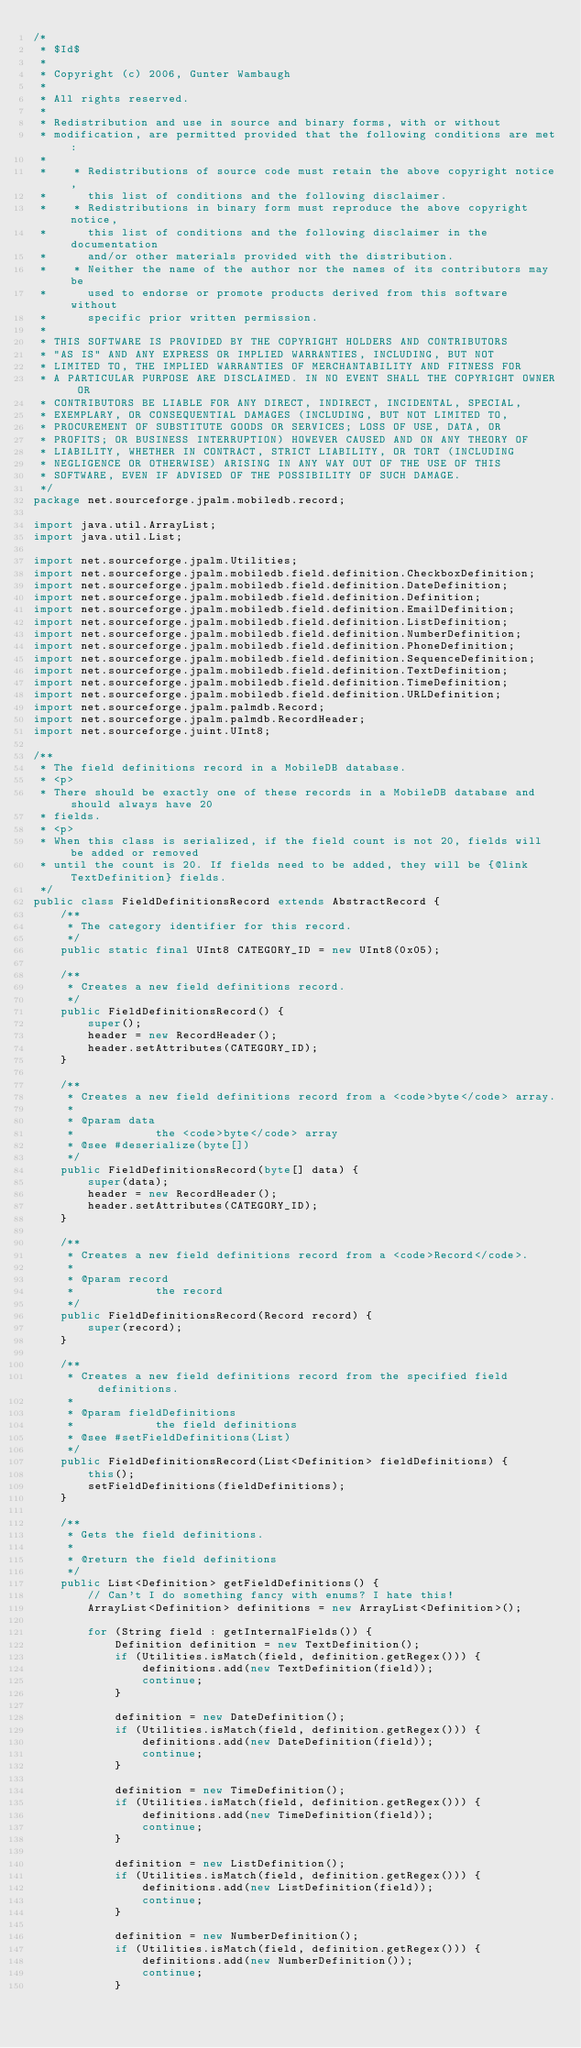Convert code to text. <code><loc_0><loc_0><loc_500><loc_500><_Java_>/*
 * $Id$
 * 
 * Copyright (c) 2006, Gunter Wambaugh
 * 
 * All rights reserved.
 * 
 * Redistribution and use in source and binary forms, with or without
 * modification, are permitted provided that the following conditions are met:
 *
 *    * Redistributions of source code must retain the above copyright notice,
 *      this list of conditions and the following disclaimer.
 *    * Redistributions in binary form must reproduce the above copyright notice,
 *      this list of conditions and the following disclaimer in the documentation
 *      and/or other materials provided with the distribution.
 *    * Neither the name of the author nor the names of its contributors may be
 *      used to endorse or promote products derived from this software without 
 *      specific prior written permission.
 *
 * THIS SOFTWARE IS PROVIDED BY THE COPYRIGHT HOLDERS AND CONTRIBUTORS
 * "AS IS" AND ANY EXPRESS OR IMPLIED WARRANTIES, INCLUDING, BUT NOT
 * LIMITED TO, THE IMPLIED WARRANTIES OF MERCHANTABILITY AND FITNESS FOR
 * A PARTICULAR PURPOSE ARE DISCLAIMED. IN NO EVENT SHALL THE COPYRIGHT OWNER OR
 * CONTRIBUTORS BE LIABLE FOR ANY DIRECT, INDIRECT, INCIDENTAL, SPECIAL,
 * EXEMPLARY, OR CONSEQUENTIAL DAMAGES (INCLUDING, BUT NOT LIMITED TO,
 * PROCUREMENT OF SUBSTITUTE GOODS OR SERVICES; LOSS OF USE, DATA, OR
 * PROFITS; OR BUSINESS INTERRUPTION) HOWEVER CAUSED AND ON ANY THEORY OF
 * LIABILITY, WHETHER IN CONTRACT, STRICT LIABILITY, OR TORT (INCLUDING
 * NEGLIGENCE OR OTHERWISE) ARISING IN ANY WAY OUT OF THE USE OF THIS
 * SOFTWARE, EVEN IF ADVISED OF THE POSSIBILITY OF SUCH DAMAGE.
 */
package net.sourceforge.jpalm.mobiledb.record;

import java.util.ArrayList;
import java.util.List;

import net.sourceforge.jpalm.Utilities;
import net.sourceforge.jpalm.mobiledb.field.definition.CheckboxDefinition;
import net.sourceforge.jpalm.mobiledb.field.definition.DateDefinition;
import net.sourceforge.jpalm.mobiledb.field.definition.Definition;
import net.sourceforge.jpalm.mobiledb.field.definition.EmailDefinition;
import net.sourceforge.jpalm.mobiledb.field.definition.ListDefinition;
import net.sourceforge.jpalm.mobiledb.field.definition.NumberDefinition;
import net.sourceforge.jpalm.mobiledb.field.definition.PhoneDefinition;
import net.sourceforge.jpalm.mobiledb.field.definition.SequenceDefinition;
import net.sourceforge.jpalm.mobiledb.field.definition.TextDefinition;
import net.sourceforge.jpalm.mobiledb.field.definition.TimeDefinition;
import net.sourceforge.jpalm.mobiledb.field.definition.URLDefinition;
import net.sourceforge.jpalm.palmdb.Record;
import net.sourceforge.jpalm.palmdb.RecordHeader;
import net.sourceforge.juint.UInt8;

/**
 * The field definitions record in a MobileDB database.
 * <p>
 * There should be exactly one of these records in a MobileDB database and should always have 20
 * fields.
 * <p>
 * When this class is serialized, if the field count is not 20, fields will be added or removed
 * until the count is 20. If fields need to be added, they will be {@link TextDefinition} fields.
 */
public class FieldDefinitionsRecord extends AbstractRecord {
    /**
     * The category identifier for this record.
     */
    public static final UInt8 CATEGORY_ID = new UInt8(0x05);

    /**
     * Creates a new field definitions record.
     */
    public FieldDefinitionsRecord() {
        super();
        header = new RecordHeader();
        header.setAttributes(CATEGORY_ID);
    }

    /**
     * Creates a new field definitions record from a <code>byte</code> array.
     * 
     * @param data
     *            the <code>byte</code> array
     * @see #deserialize(byte[])
     */
    public FieldDefinitionsRecord(byte[] data) {
        super(data);
        header = new RecordHeader();
        header.setAttributes(CATEGORY_ID);
    }

    /**
     * Creates a new field definitions record from a <code>Record</code>.
     * 
     * @param record
     *            the record
     */
    public FieldDefinitionsRecord(Record record) {
        super(record);
    }

    /**
     * Creates a new field definitions record from the specified field definitions.
     * 
     * @param fieldDefinitions
     *            the field definitions
     * @see #setFieldDefinitions(List)
     */
    public FieldDefinitionsRecord(List<Definition> fieldDefinitions) {
        this();
        setFieldDefinitions(fieldDefinitions);
    }

    /**
     * Gets the field definitions.
     * 
     * @return the field definitions
     */
    public List<Definition> getFieldDefinitions() {
        // Can't I do something fancy with enums? I hate this!
        ArrayList<Definition> definitions = new ArrayList<Definition>();

        for (String field : getInternalFields()) {
            Definition definition = new TextDefinition();
            if (Utilities.isMatch(field, definition.getRegex())) {
                definitions.add(new TextDefinition(field));
                continue;
            }

            definition = new DateDefinition();
            if (Utilities.isMatch(field, definition.getRegex())) {
                definitions.add(new DateDefinition(field));
                continue;
            }

            definition = new TimeDefinition();
            if (Utilities.isMatch(field, definition.getRegex())) {
                definitions.add(new TimeDefinition(field));
                continue;
            }

            definition = new ListDefinition();
            if (Utilities.isMatch(field, definition.getRegex())) {
                definitions.add(new ListDefinition(field));
                continue;
            }

            definition = new NumberDefinition();
            if (Utilities.isMatch(field, definition.getRegex())) {
                definitions.add(new NumberDefinition());
                continue;
            }
</code> 